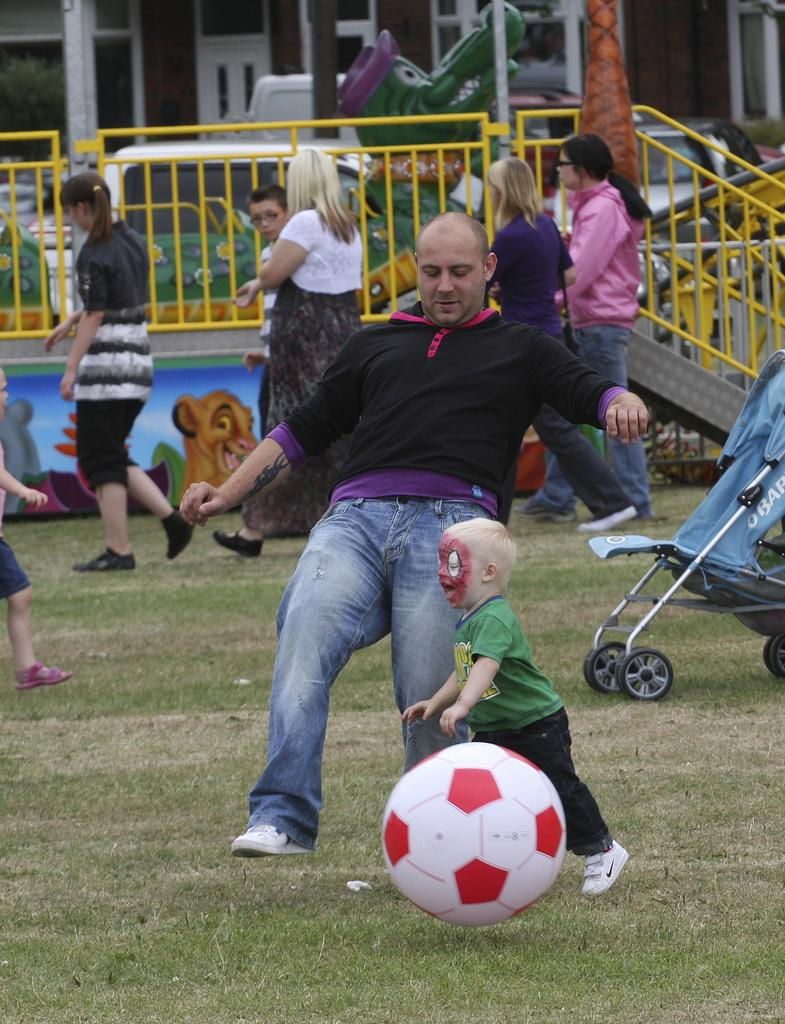What is happening in the image involving multiple people? There is a group of persons in the image, and they are walking. Can you describe the activity involving a person and a kid in the image? The person and the kid are playing with a ball. How many individuals are involved in the activity with the ball? There are two individuals involved, a person and a kid. What book is the representative holding in the image? There is no book or representative present in the image. Is there any ice visible in the image? No, there is no ice visible in the image. 